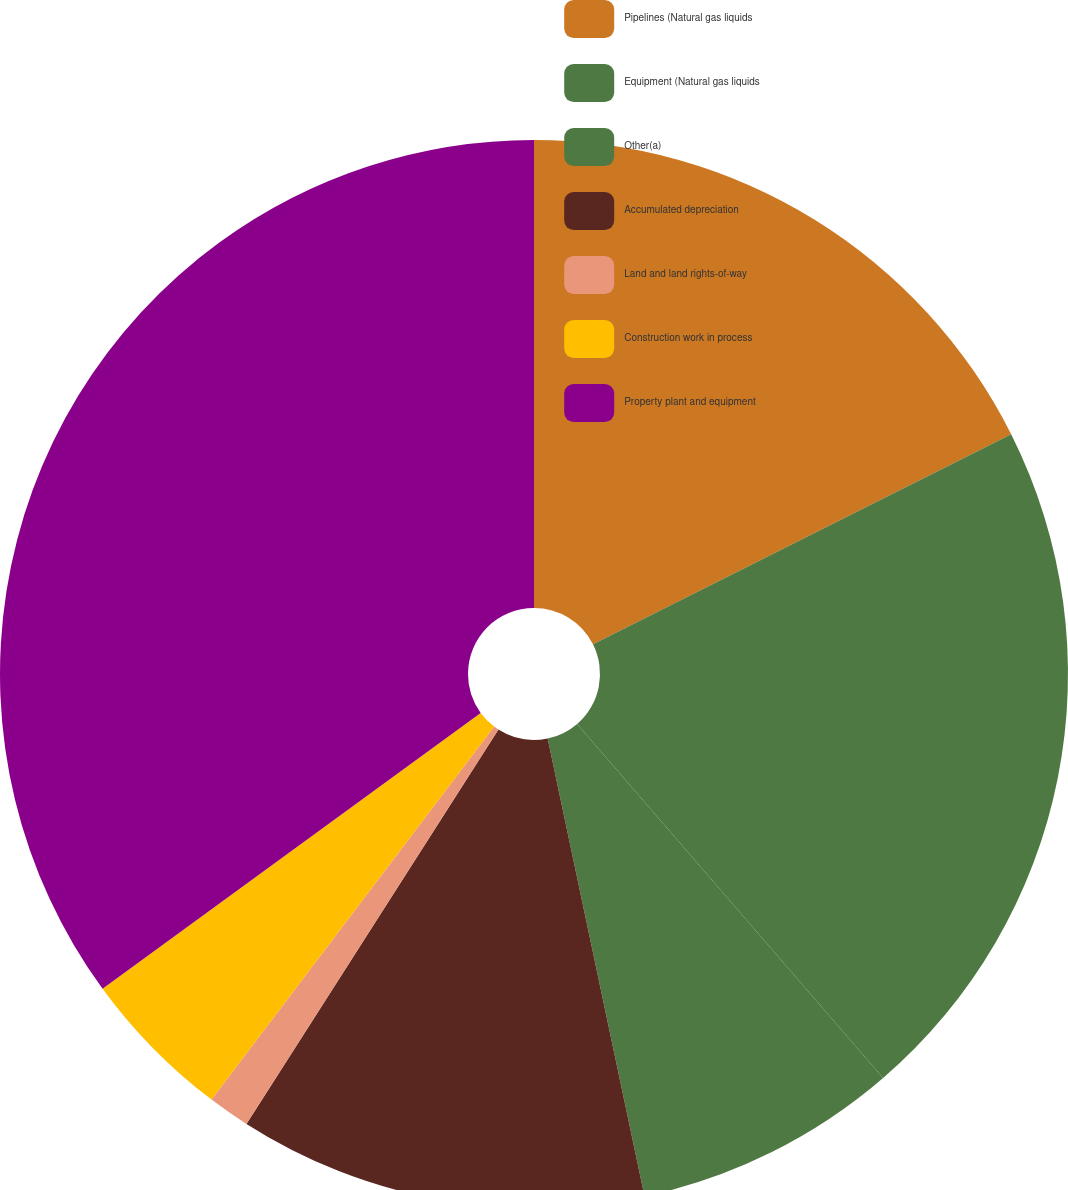Convert chart. <chart><loc_0><loc_0><loc_500><loc_500><pie_chart><fcel>Pipelines (Natural gas liquids<fcel>Equipment (Natural gas liquids<fcel>Other(a)<fcel>Accumulated depreciation<fcel>Land and land rights-of-way<fcel>Construction work in process<fcel>Property plant and equipment<nl><fcel>17.59%<fcel>21.07%<fcel>8.02%<fcel>12.37%<fcel>1.27%<fcel>4.65%<fcel>35.03%<nl></chart> 